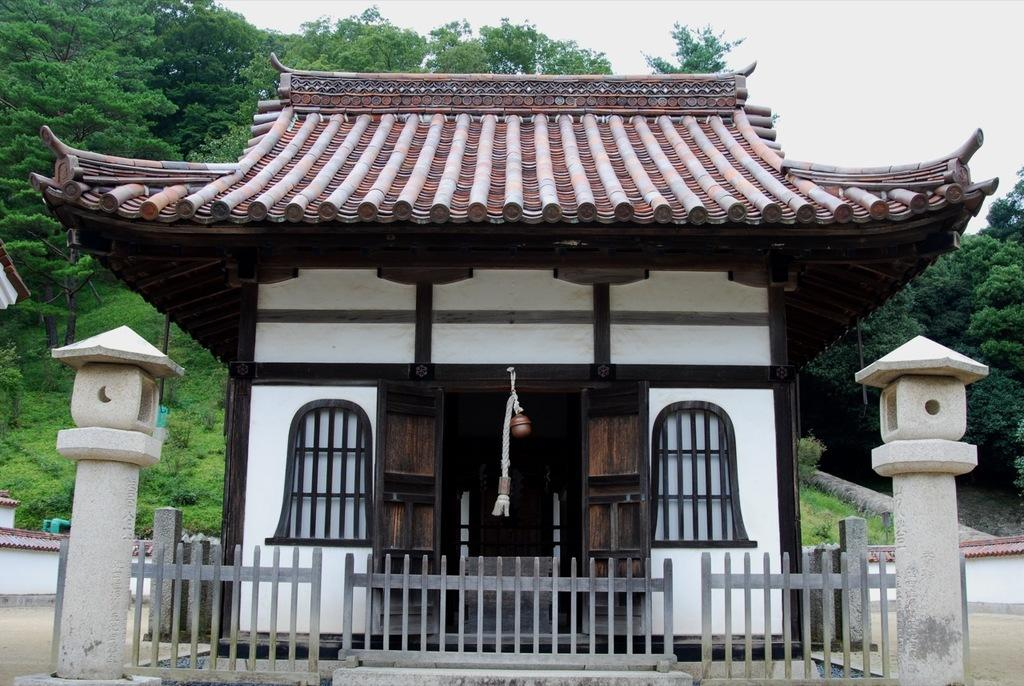What is the main structure in the image? There is a big building in the image. What is in front of the building? There is a fence with pillars in front of the building. What can be seen behind the building? There is a mountain behind the building. What type of vegetation is present on the mountain? Trees are present on the mountain, and grass is visible on the mountain. What color is the tongue of the person standing in front of the building? There is no person with a visible tongue present in the image. 